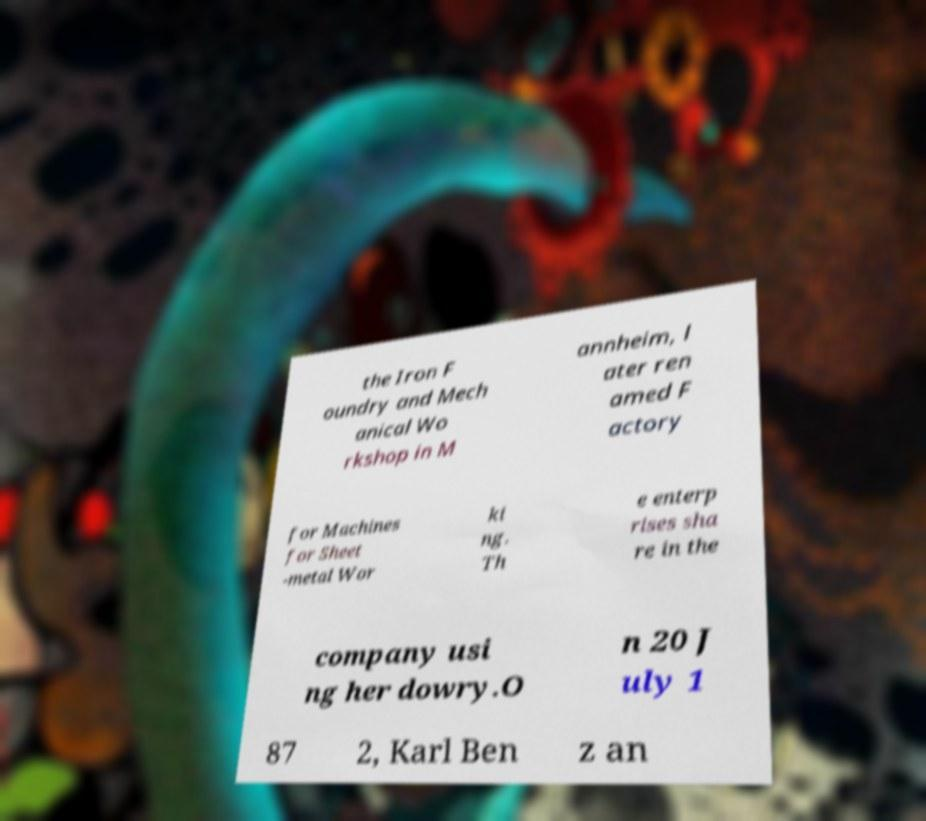There's text embedded in this image that I need extracted. Can you transcribe it verbatim? the Iron F oundry and Mech anical Wo rkshop in M annheim, l ater ren amed F actory for Machines for Sheet -metal Wor ki ng. Th e enterp rises sha re in the company usi ng her dowry.O n 20 J uly 1 87 2, Karl Ben z an 